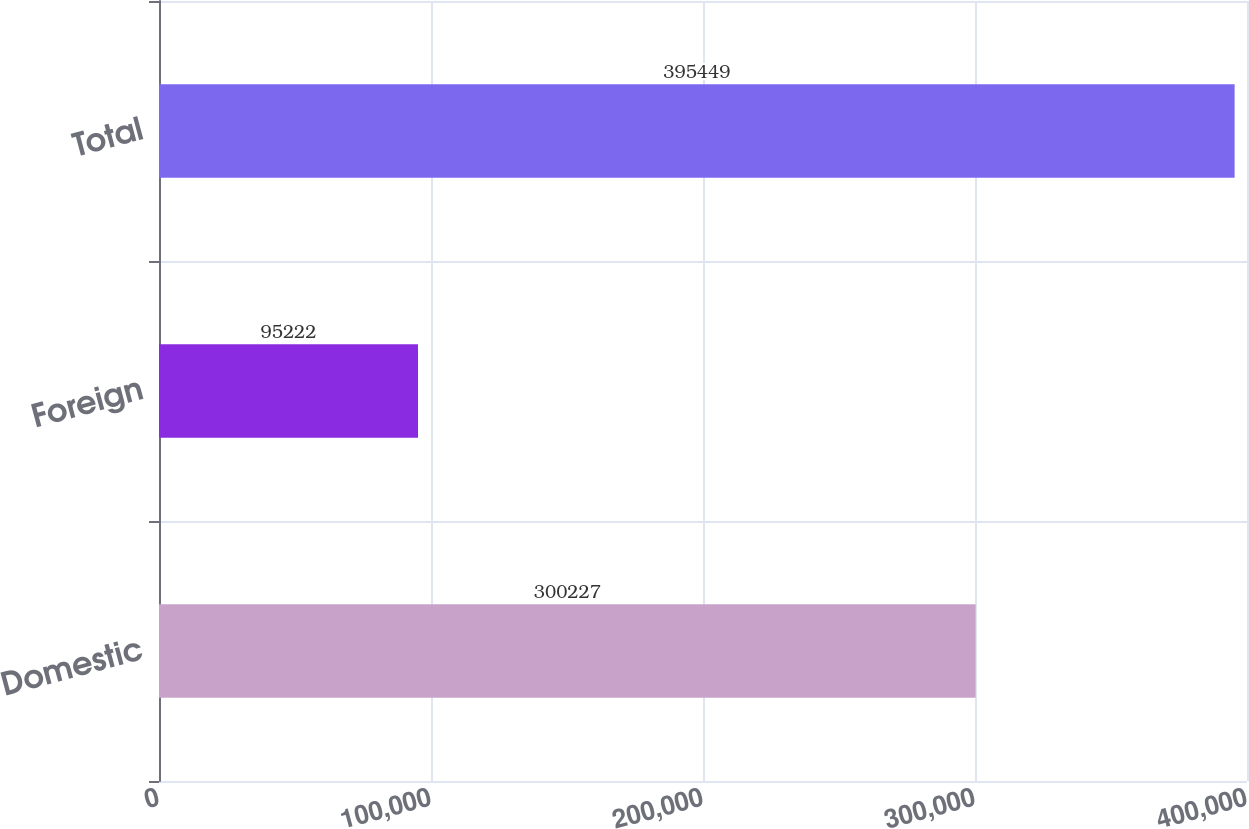Convert chart to OTSL. <chart><loc_0><loc_0><loc_500><loc_500><bar_chart><fcel>Domestic<fcel>Foreign<fcel>Total<nl><fcel>300227<fcel>95222<fcel>395449<nl></chart> 